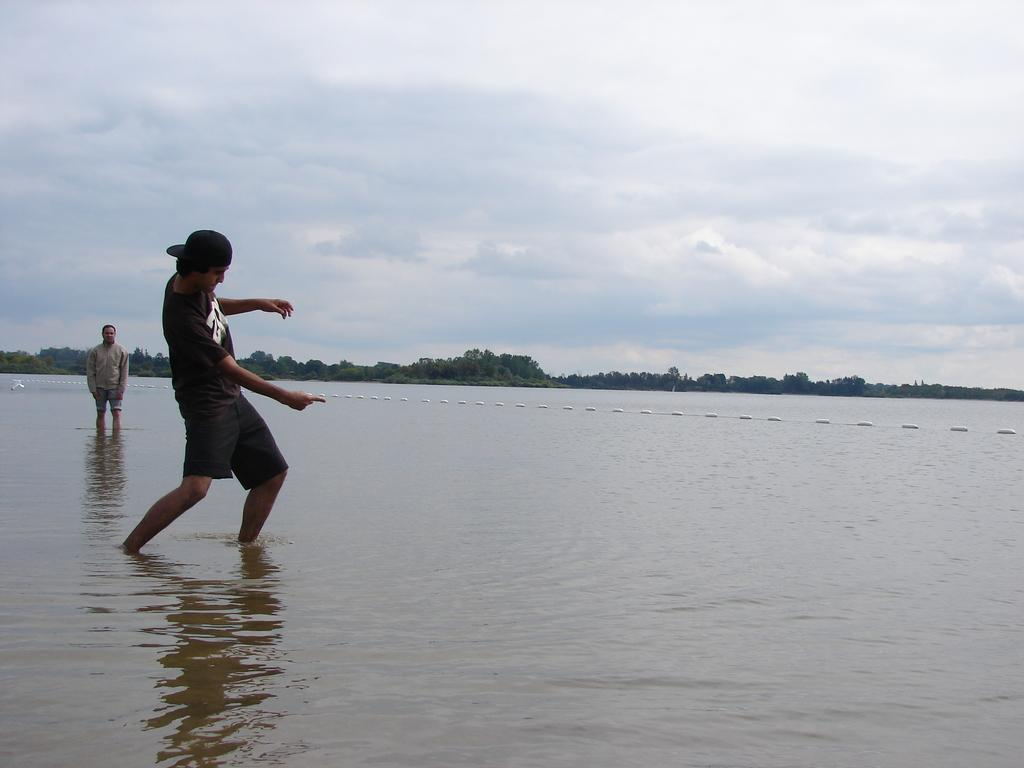How many people are in the water in the image? There are two people standing in the water in the image. What can be seen in the background of the image? There are trees visible in the background. How would you describe the sky in the image? The sky is cloudy in the image. What type of comfort can be seen being offered by the trees in the image? The trees in the image are not offering any comfort, as they are simply part of the background. 